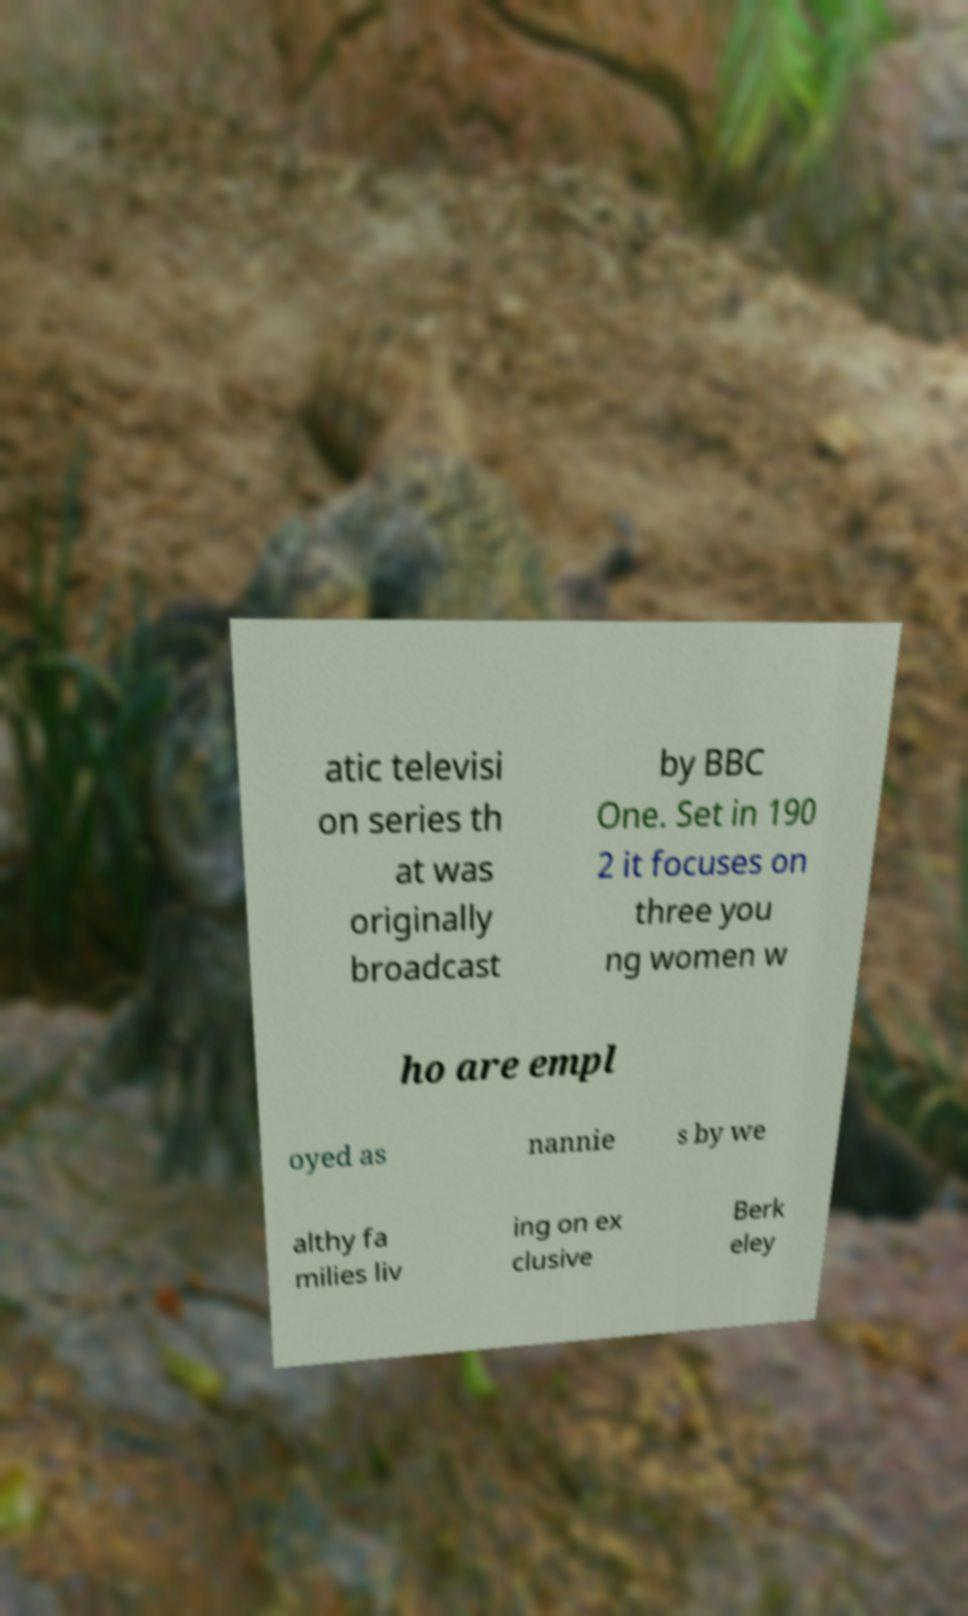There's text embedded in this image that I need extracted. Can you transcribe it verbatim? atic televisi on series th at was originally broadcast by BBC One. Set in 190 2 it focuses on three you ng women w ho are empl oyed as nannie s by we althy fa milies liv ing on ex clusive Berk eley 